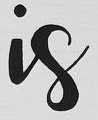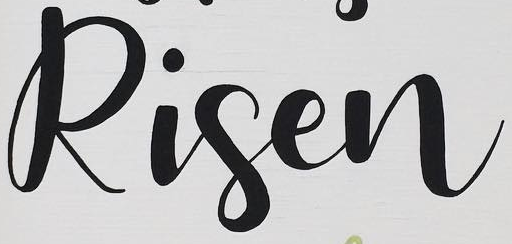What text appears in these images from left to right, separated by a semicolon? is; Risen 